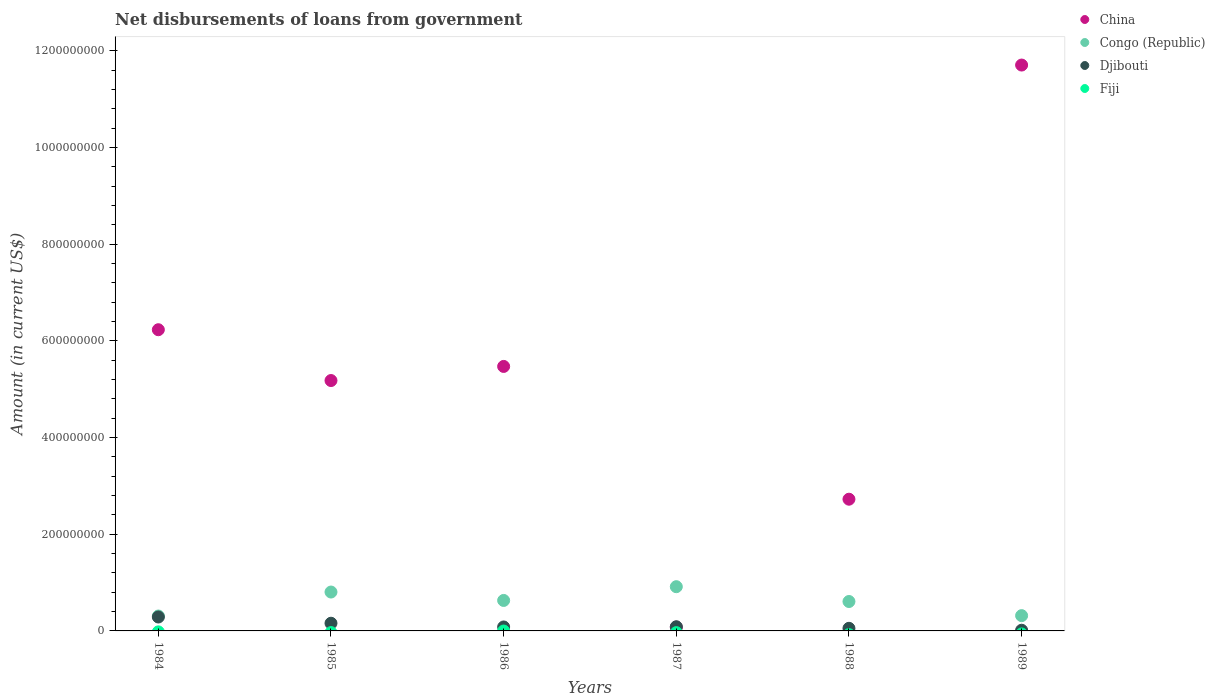How many different coloured dotlines are there?
Ensure brevity in your answer.  3. What is the amount of loan disbursed from government in Congo (Republic) in 1988?
Offer a terse response. 6.09e+07. Across all years, what is the maximum amount of loan disbursed from government in Congo (Republic)?
Provide a short and direct response. 9.15e+07. Across all years, what is the minimum amount of loan disbursed from government in Congo (Republic)?
Keep it short and to the point. 3.08e+07. What is the total amount of loan disbursed from government in China in the graph?
Your answer should be compact. 3.14e+09. What is the difference between the amount of loan disbursed from government in China in 1984 and that in 1989?
Ensure brevity in your answer.  -5.48e+08. What is the difference between the amount of loan disbursed from government in Congo (Republic) in 1985 and the amount of loan disbursed from government in Djibouti in 1986?
Ensure brevity in your answer.  7.22e+07. What is the average amount of loan disbursed from government in Djibouti per year?
Give a very brief answer. 1.14e+07. In the year 1989, what is the difference between the amount of loan disbursed from government in Djibouti and amount of loan disbursed from government in China?
Give a very brief answer. -1.17e+09. In how many years, is the amount of loan disbursed from government in Djibouti greater than 800000000 US$?
Give a very brief answer. 0. What is the ratio of the amount of loan disbursed from government in Congo (Republic) in 1986 to that in 1988?
Offer a very short reply. 1.04. What is the difference between the highest and the second highest amount of loan disbursed from government in Congo (Republic)?
Provide a succinct answer. 1.11e+07. What is the difference between the highest and the lowest amount of loan disbursed from government in Djibouti?
Your response must be concise. 2.74e+07. Is it the case that in every year, the sum of the amount of loan disbursed from government in Congo (Republic) and amount of loan disbursed from government in Djibouti  is greater than the sum of amount of loan disbursed from government in Fiji and amount of loan disbursed from government in China?
Offer a very short reply. No. Does the amount of loan disbursed from government in China monotonically increase over the years?
Provide a succinct answer. No. Is the amount of loan disbursed from government in Fiji strictly less than the amount of loan disbursed from government in Congo (Republic) over the years?
Your answer should be compact. Yes. How many dotlines are there?
Offer a very short reply. 3. Are the values on the major ticks of Y-axis written in scientific E-notation?
Provide a short and direct response. No. Does the graph contain any zero values?
Your answer should be compact. Yes. Where does the legend appear in the graph?
Your response must be concise. Top right. How many legend labels are there?
Keep it short and to the point. 4. What is the title of the graph?
Provide a succinct answer. Net disbursements of loans from government. Does "East Asia (developing only)" appear as one of the legend labels in the graph?
Offer a very short reply. No. What is the label or title of the X-axis?
Your answer should be very brief. Years. What is the Amount (in current US$) of China in 1984?
Your response must be concise. 6.23e+08. What is the Amount (in current US$) of Congo (Republic) in 1984?
Provide a short and direct response. 3.08e+07. What is the Amount (in current US$) in Djibouti in 1984?
Offer a very short reply. 2.88e+07. What is the Amount (in current US$) of China in 1985?
Your response must be concise. 5.18e+08. What is the Amount (in current US$) of Congo (Republic) in 1985?
Keep it short and to the point. 8.04e+07. What is the Amount (in current US$) of Djibouti in 1985?
Provide a short and direct response. 1.59e+07. What is the Amount (in current US$) of Fiji in 1985?
Provide a succinct answer. 0. What is the Amount (in current US$) of China in 1986?
Provide a short and direct response. 5.47e+08. What is the Amount (in current US$) in Congo (Republic) in 1986?
Keep it short and to the point. 6.30e+07. What is the Amount (in current US$) of Djibouti in 1986?
Your response must be concise. 8.19e+06. What is the Amount (in current US$) in Fiji in 1986?
Keep it short and to the point. 0. What is the Amount (in current US$) in China in 1987?
Your answer should be compact. 7.75e+06. What is the Amount (in current US$) of Congo (Republic) in 1987?
Your answer should be compact. 9.15e+07. What is the Amount (in current US$) of Djibouti in 1987?
Ensure brevity in your answer.  8.63e+06. What is the Amount (in current US$) of China in 1988?
Your answer should be compact. 2.72e+08. What is the Amount (in current US$) in Congo (Republic) in 1988?
Your answer should be very brief. 6.09e+07. What is the Amount (in current US$) in Djibouti in 1988?
Your answer should be compact. 5.40e+06. What is the Amount (in current US$) of China in 1989?
Provide a succinct answer. 1.17e+09. What is the Amount (in current US$) in Congo (Republic) in 1989?
Provide a short and direct response. 3.16e+07. What is the Amount (in current US$) of Djibouti in 1989?
Your answer should be very brief. 1.43e+06. What is the Amount (in current US$) of Fiji in 1989?
Provide a short and direct response. 0. Across all years, what is the maximum Amount (in current US$) of China?
Keep it short and to the point. 1.17e+09. Across all years, what is the maximum Amount (in current US$) in Congo (Republic)?
Offer a terse response. 9.15e+07. Across all years, what is the maximum Amount (in current US$) of Djibouti?
Make the answer very short. 2.88e+07. Across all years, what is the minimum Amount (in current US$) in China?
Offer a very short reply. 7.75e+06. Across all years, what is the minimum Amount (in current US$) of Congo (Republic)?
Ensure brevity in your answer.  3.08e+07. Across all years, what is the minimum Amount (in current US$) of Djibouti?
Your answer should be compact. 1.43e+06. What is the total Amount (in current US$) in China in the graph?
Keep it short and to the point. 3.14e+09. What is the total Amount (in current US$) in Congo (Republic) in the graph?
Your answer should be compact. 3.58e+08. What is the total Amount (in current US$) in Djibouti in the graph?
Keep it short and to the point. 6.83e+07. What is the difference between the Amount (in current US$) of China in 1984 and that in 1985?
Provide a succinct answer. 1.05e+08. What is the difference between the Amount (in current US$) of Congo (Republic) in 1984 and that in 1985?
Provide a succinct answer. -4.96e+07. What is the difference between the Amount (in current US$) in Djibouti in 1984 and that in 1985?
Provide a succinct answer. 1.29e+07. What is the difference between the Amount (in current US$) in China in 1984 and that in 1986?
Ensure brevity in your answer.  7.59e+07. What is the difference between the Amount (in current US$) of Congo (Republic) in 1984 and that in 1986?
Provide a short and direct response. -3.22e+07. What is the difference between the Amount (in current US$) in Djibouti in 1984 and that in 1986?
Your answer should be compact. 2.06e+07. What is the difference between the Amount (in current US$) in China in 1984 and that in 1987?
Your answer should be compact. 6.15e+08. What is the difference between the Amount (in current US$) of Congo (Republic) in 1984 and that in 1987?
Ensure brevity in your answer.  -6.07e+07. What is the difference between the Amount (in current US$) of Djibouti in 1984 and that in 1987?
Make the answer very short. 2.02e+07. What is the difference between the Amount (in current US$) in China in 1984 and that in 1988?
Your response must be concise. 3.51e+08. What is the difference between the Amount (in current US$) in Congo (Republic) in 1984 and that in 1988?
Your response must be concise. -3.00e+07. What is the difference between the Amount (in current US$) in Djibouti in 1984 and that in 1988?
Give a very brief answer. 2.34e+07. What is the difference between the Amount (in current US$) of China in 1984 and that in 1989?
Offer a very short reply. -5.48e+08. What is the difference between the Amount (in current US$) in Congo (Republic) in 1984 and that in 1989?
Your answer should be compact. -7.80e+05. What is the difference between the Amount (in current US$) in Djibouti in 1984 and that in 1989?
Your answer should be very brief. 2.74e+07. What is the difference between the Amount (in current US$) of China in 1985 and that in 1986?
Keep it short and to the point. -2.92e+07. What is the difference between the Amount (in current US$) in Congo (Republic) in 1985 and that in 1986?
Give a very brief answer. 1.74e+07. What is the difference between the Amount (in current US$) of Djibouti in 1985 and that in 1986?
Offer a very short reply. 7.72e+06. What is the difference between the Amount (in current US$) of China in 1985 and that in 1987?
Ensure brevity in your answer.  5.10e+08. What is the difference between the Amount (in current US$) of Congo (Republic) in 1985 and that in 1987?
Your answer should be very brief. -1.11e+07. What is the difference between the Amount (in current US$) in Djibouti in 1985 and that in 1987?
Ensure brevity in your answer.  7.28e+06. What is the difference between the Amount (in current US$) of China in 1985 and that in 1988?
Your response must be concise. 2.45e+08. What is the difference between the Amount (in current US$) of Congo (Republic) in 1985 and that in 1988?
Provide a succinct answer. 1.96e+07. What is the difference between the Amount (in current US$) of Djibouti in 1985 and that in 1988?
Offer a terse response. 1.05e+07. What is the difference between the Amount (in current US$) of China in 1985 and that in 1989?
Offer a very short reply. -6.53e+08. What is the difference between the Amount (in current US$) of Congo (Republic) in 1985 and that in 1989?
Ensure brevity in your answer.  4.88e+07. What is the difference between the Amount (in current US$) in Djibouti in 1985 and that in 1989?
Provide a succinct answer. 1.45e+07. What is the difference between the Amount (in current US$) in China in 1986 and that in 1987?
Your answer should be compact. 5.39e+08. What is the difference between the Amount (in current US$) of Congo (Republic) in 1986 and that in 1987?
Ensure brevity in your answer.  -2.85e+07. What is the difference between the Amount (in current US$) in Djibouti in 1986 and that in 1987?
Give a very brief answer. -4.40e+05. What is the difference between the Amount (in current US$) of China in 1986 and that in 1988?
Make the answer very short. 2.75e+08. What is the difference between the Amount (in current US$) in Congo (Republic) in 1986 and that in 1988?
Provide a succinct answer. 2.18e+06. What is the difference between the Amount (in current US$) in Djibouti in 1986 and that in 1988?
Give a very brief answer. 2.79e+06. What is the difference between the Amount (in current US$) of China in 1986 and that in 1989?
Provide a short and direct response. -6.23e+08. What is the difference between the Amount (in current US$) in Congo (Republic) in 1986 and that in 1989?
Provide a succinct answer. 3.14e+07. What is the difference between the Amount (in current US$) in Djibouti in 1986 and that in 1989?
Make the answer very short. 6.76e+06. What is the difference between the Amount (in current US$) of China in 1987 and that in 1988?
Give a very brief answer. -2.65e+08. What is the difference between the Amount (in current US$) in Congo (Republic) in 1987 and that in 1988?
Ensure brevity in your answer.  3.06e+07. What is the difference between the Amount (in current US$) in Djibouti in 1987 and that in 1988?
Ensure brevity in your answer.  3.23e+06. What is the difference between the Amount (in current US$) in China in 1987 and that in 1989?
Give a very brief answer. -1.16e+09. What is the difference between the Amount (in current US$) in Congo (Republic) in 1987 and that in 1989?
Provide a short and direct response. 5.99e+07. What is the difference between the Amount (in current US$) of Djibouti in 1987 and that in 1989?
Give a very brief answer. 7.20e+06. What is the difference between the Amount (in current US$) of China in 1988 and that in 1989?
Offer a terse response. -8.98e+08. What is the difference between the Amount (in current US$) in Congo (Republic) in 1988 and that in 1989?
Give a very brief answer. 2.92e+07. What is the difference between the Amount (in current US$) in Djibouti in 1988 and that in 1989?
Provide a succinct answer. 3.97e+06. What is the difference between the Amount (in current US$) in China in 1984 and the Amount (in current US$) in Congo (Republic) in 1985?
Your answer should be compact. 5.43e+08. What is the difference between the Amount (in current US$) of China in 1984 and the Amount (in current US$) of Djibouti in 1985?
Make the answer very short. 6.07e+08. What is the difference between the Amount (in current US$) of Congo (Republic) in 1984 and the Amount (in current US$) of Djibouti in 1985?
Keep it short and to the point. 1.49e+07. What is the difference between the Amount (in current US$) in China in 1984 and the Amount (in current US$) in Congo (Republic) in 1986?
Your answer should be very brief. 5.60e+08. What is the difference between the Amount (in current US$) of China in 1984 and the Amount (in current US$) of Djibouti in 1986?
Provide a short and direct response. 6.15e+08. What is the difference between the Amount (in current US$) in Congo (Republic) in 1984 and the Amount (in current US$) in Djibouti in 1986?
Offer a terse response. 2.26e+07. What is the difference between the Amount (in current US$) in China in 1984 and the Amount (in current US$) in Congo (Republic) in 1987?
Your answer should be compact. 5.32e+08. What is the difference between the Amount (in current US$) in China in 1984 and the Amount (in current US$) in Djibouti in 1987?
Provide a succinct answer. 6.14e+08. What is the difference between the Amount (in current US$) of Congo (Republic) in 1984 and the Amount (in current US$) of Djibouti in 1987?
Give a very brief answer. 2.22e+07. What is the difference between the Amount (in current US$) in China in 1984 and the Amount (in current US$) in Congo (Republic) in 1988?
Provide a succinct answer. 5.62e+08. What is the difference between the Amount (in current US$) of China in 1984 and the Amount (in current US$) of Djibouti in 1988?
Ensure brevity in your answer.  6.18e+08. What is the difference between the Amount (in current US$) in Congo (Republic) in 1984 and the Amount (in current US$) in Djibouti in 1988?
Your answer should be very brief. 2.54e+07. What is the difference between the Amount (in current US$) of China in 1984 and the Amount (in current US$) of Congo (Republic) in 1989?
Your response must be concise. 5.91e+08. What is the difference between the Amount (in current US$) in China in 1984 and the Amount (in current US$) in Djibouti in 1989?
Ensure brevity in your answer.  6.22e+08. What is the difference between the Amount (in current US$) in Congo (Republic) in 1984 and the Amount (in current US$) in Djibouti in 1989?
Ensure brevity in your answer.  2.94e+07. What is the difference between the Amount (in current US$) of China in 1985 and the Amount (in current US$) of Congo (Republic) in 1986?
Keep it short and to the point. 4.55e+08. What is the difference between the Amount (in current US$) in China in 1985 and the Amount (in current US$) in Djibouti in 1986?
Offer a very short reply. 5.10e+08. What is the difference between the Amount (in current US$) in Congo (Republic) in 1985 and the Amount (in current US$) in Djibouti in 1986?
Your response must be concise. 7.22e+07. What is the difference between the Amount (in current US$) in China in 1985 and the Amount (in current US$) in Congo (Republic) in 1987?
Ensure brevity in your answer.  4.26e+08. What is the difference between the Amount (in current US$) in China in 1985 and the Amount (in current US$) in Djibouti in 1987?
Provide a succinct answer. 5.09e+08. What is the difference between the Amount (in current US$) of Congo (Republic) in 1985 and the Amount (in current US$) of Djibouti in 1987?
Your answer should be very brief. 7.18e+07. What is the difference between the Amount (in current US$) in China in 1985 and the Amount (in current US$) in Congo (Republic) in 1988?
Ensure brevity in your answer.  4.57e+08. What is the difference between the Amount (in current US$) of China in 1985 and the Amount (in current US$) of Djibouti in 1988?
Offer a terse response. 5.13e+08. What is the difference between the Amount (in current US$) in Congo (Republic) in 1985 and the Amount (in current US$) in Djibouti in 1988?
Your answer should be very brief. 7.50e+07. What is the difference between the Amount (in current US$) of China in 1985 and the Amount (in current US$) of Congo (Republic) in 1989?
Offer a very short reply. 4.86e+08. What is the difference between the Amount (in current US$) in China in 1985 and the Amount (in current US$) in Djibouti in 1989?
Keep it short and to the point. 5.17e+08. What is the difference between the Amount (in current US$) of Congo (Republic) in 1985 and the Amount (in current US$) of Djibouti in 1989?
Offer a terse response. 7.90e+07. What is the difference between the Amount (in current US$) in China in 1986 and the Amount (in current US$) in Congo (Republic) in 1987?
Provide a succinct answer. 4.56e+08. What is the difference between the Amount (in current US$) of China in 1986 and the Amount (in current US$) of Djibouti in 1987?
Give a very brief answer. 5.39e+08. What is the difference between the Amount (in current US$) in Congo (Republic) in 1986 and the Amount (in current US$) in Djibouti in 1987?
Your answer should be very brief. 5.44e+07. What is the difference between the Amount (in current US$) of China in 1986 and the Amount (in current US$) of Congo (Republic) in 1988?
Offer a terse response. 4.86e+08. What is the difference between the Amount (in current US$) of China in 1986 and the Amount (in current US$) of Djibouti in 1988?
Provide a succinct answer. 5.42e+08. What is the difference between the Amount (in current US$) of Congo (Republic) in 1986 and the Amount (in current US$) of Djibouti in 1988?
Ensure brevity in your answer.  5.76e+07. What is the difference between the Amount (in current US$) in China in 1986 and the Amount (in current US$) in Congo (Republic) in 1989?
Your answer should be very brief. 5.16e+08. What is the difference between the Amount (in current US$) in China in 1986 and the Amount (in current US$) in Djibouti in 1989?
Your answer should be very brief. 5.46e+08. What is the difference between the Amount (in current US$) in Congo (Republic) in 1986 and the Amount (in current US$) in Djibouti in 1989?
Your answer should be compact. 6.16e+07. What is the difference between the Amount (in current US$) of China in 1987 and the Amount (in current US$) of Congo (Republic) in 1988?
Provide a short and direct response. -5.31e+07. What is the difference between the Amount (in current US$) in China in 1987 and the Amount (in current US$) in Djibouti in 1988?
Ensure brevity in your answer.  2.35e+06. What is the difference between the Amount (in current US$) of Congo (Republic) in 1987 and the Amount (in current US$) of Djibouti in 1988?
Your response must be concise. 8.61e+07. What is the difference between the Amount (in current US$) of China in 1987 and the Amount (in current US$) of Congo (Republic) in 1989?
Your answer should be very brief. -2.39e+07. What is the difference between the Amount (in current US$) of China in 1987 and the Amount (in current US$) of Djibouti in 1989?
Your answer should be very brief. 6.32e+06. What is the difference between the Amount (in current US$) in Congo (Republic) in 1987 and the Amount (in current US$) in Djibouti in 1989?
Your answer should be very brief. 9.01e+07. What is the difference between the Amount (in current US$) in China in 1988 and the Amount (in current US$) in Congo (Republic) in 1989?
Your answer should be compact. 2.41e+08. What is the difference between the Amount (in current US$) in China in 1988 and the Amount (in current US$) in Djibouti in 1989?
Offer a terse response. 2.71e+08. What is the difference between the Amount (in current US$) of Congo (Republic) in 1988 and the Amount (in current US$) of Djibouti in 1989?
Provide a short and direct response. 5.94e+07. What is the average Amount (in current US$) of China per year?
Your response must be concise. 5.23e+08. What is the average Amount (in current US$) in Congo (Republic) per year?
Your answer should be compact. 5.97e+07. What is the average Amount (in current US$) of Djibouti per year?
Provide a succinct answer. 1.14e+07. In the year 1984, what is the difference between the Amount (in current US$) in China and Amount (in current US$) in Congo (Republic)?
Provide a succinct answer. 5.92e+08. In the year 1984, what is the difference between the Amount (in current US$) in China and Amount (in current US$) in Djibouti?
Give a very brief answer. 5.94e+08. In the year 1984, what is the difference between the Amount (in current US$) in Congo (Republic) and Amount (in current US$) in Djibouti?
Provide a short and direct response. 2.04e+06. In the year 1985, what is the difference between the Amount (in current US$) of China and Amount (in current US$) of Congo (Republic)?
Your response must be concise. 4.38e+08. In the year 1985, what is the difference between the Amount (in current US$) in China and Amount (in current US$) in Djibouti?
Offer a terse response. 5.02e+08. In the year 1985, what is the difference between the Amount (in current US$) in Congo (Republic) and Amount (in current US$) in Djibouti?
Keep it short and to the point. 6.45e+07. In the year 1986, what is the difference between the Amount (in current US$) in China and Amount (in current US$) in Congo (Republic)?
Make the answer very short. 4.84e+08. In the year 1986, what is the difference between the Amount (in current US$) of China and Amount (in current US$) of Djibouti?
Your answer should be compact. 5.39e+08. In the year 1986, what is the difference between the Amount (in current US$) of Congo (Republic) and Amount (in current US$) of Djibouti?
Your response must be concise. 5.48e+07. In the year 1987, what is the difference between the Amount (in current US$) in China and Amount (in current US$) in Congo (Republic)?
Keep it short and to the point. -8.37e+07. In the year 1987, what is the difference between the Amount (in current US$) of China and Amount (in current US$) of Djibouti?
Your answer should be compact. -8.79e+05. In the year 1987, what is the difference between the Amount (in current US$) of Congo (Republic) and Amount (in current US$) of Djibouti?
Offer a very short reply. 8.29e+07. In the year 1988, what is the difference between the Amount (in current US$) of China and Amount (in current US$) of Congo (Republic)?
Ensure brevity in your answer.  2.12e+08. In the year 1988, what is the difference between the Amount (in current US$) of China and Amount (in current US$) of Djibouti?
Keep it short and to the point. 2.67e+08. In the year 1988, what is the difference between the Amount (in current US$) in Congo (Republic) and Amount (in current US$) in Djibouti?
Your answer should be compact. 5.55e+07. In the year 1989, what is the difference between the Amount (in current US$) in China and Amount (in current US$) in Congo (Republic)?
Your answer should be very brief. 1.14e+09. In the year 1989, what is the difference between the Amount (in current US$) of China and Amount (in current US$) of Djibouti?
Your answer should be compact. 1.17e+09. In the year 1989, what is the difference between the Amount (in current US$) of Congo (Republic) and Amount (in current US$) of Djibouti?
Provide a succinct answer. 3.02e+07. What is the ratio of the Amount (in current US$) in China in 1984 to that in 1985?
Offer a very short reply. 1.2. What is the ratio of the Amount (in current US$) of Congo (Republic) in 1984 to that in 1985?
Ensure brevity in your answer.  0.38. What is the ratio of the Amount (in current US$) of Djibouti in 1984 to that in 1985?
Make the answer very short. 1.81. What is the ratio of the Amount (in current US$) of China in 1984 to that in 1986?
Provide a short and direct response. 1.14. What is the ratio of the Amount (in current US$) of Congo (Republic) in 1984 to that in 1986?
Offer a terse response. 0.49. What is the ratio of the Amount (in current US$) of Djibouti in 1984 to that in 1986?
Your response must be concise. 3.52. What is the ratio of the Amount (in current US$) in China in 1984 to that in 1987?
Give a very brief answer. 80.4. What is the ratio of the Amount (in current US$) in Congo (Republic) in 1984 to that in 1987?
Your response must be concise. 0.34. What is the ratio of the Amount (in current US$) of Djibouti in 1984 to that in 1987?
Provide a short and direct response. 3.34. What is the ratio of the Amount (in current US$) of China in 1984 to that in 1988?
Offer a very short reply. 2.29. What is the ratio of the Amount (in current US$) in Congo (Republic) in 1984 to that in 1988?
Provide a short and direct response. 0.51. What is the ratio of the Amount (in current US$) in Djibouti in 1984 to that in 1988?
Provide a succinct answer. 5.33. What is the ratio of the Amount (in current US$) in China in 1984 to that in 1989?
Make the answer very short. 0.53. What is the ratio of the Amount (in current US$) of Congo (Republic) in 1984 to that in 1989?
Your response must be concise. 0.98. What is the ratio of the Amount (in current US$) in Djibouti in 1984 to that in 1989?
Give a very brief answer. 20.16. What is the ratio of the Amount (in current US$) in China in 1985 to that in 1986?
Your response must be concise. 0.95. What is the ratio of the Amount (in current US$) in Congo (Republic) in 1985 to that in 1986?
Your answer should be compact. 1.28. What is the ratio of the Amount (in current US$) in Djibouti in 1985 to that in 1986?
Offer a terse response. 1.94. What is the ratio of the Amount (in current US$) of China in 1985 to that in 1987?
Provide a short and direct response. 66.83. What is the ratio of the Amount (in current US$) in Congo (Republic) in 1985 to that in 1987?
Offer a very short reply. 0.88. What is the ratio of the Amount (in current US$) in Djibouti in 1985 to that in 1987?
Your response must be concise. 1.84. What is the ratio of the Amount (in current US$) of China in 1985 to that in 1988?
Give a very brief answer. 1.9. What is the ratio of the Amount (in current US$) of Congo (Republic) in 1985 to that in 1988?
Give a very brief answer. 1.32. What is the ratio of the Amount (in current US$) in Djibouti in 1985 to that in 1988?
Your response must be concise. 2.95. What is the ratio of the Amount (in current US$) in China in 1985 to that in 1989?
Keep it short and to the point. 0.44. What is the ratio of the Amount (in current US$) of Congo (Republic) in 1985 to that in 1989?
Provide a succinct answer. 2.54. What is the ratio of the Amount (in current US$) in Djibouti in 1985 to that in 1989?
Your answer should be very brief. 11.14. What is the ratio of the Amount (in current US$) of China in 1986 to that in 1987?
Provide a succinct answer. 70.6. What is the ratio of the Amount (in current US$) in Congo (Republic) in 1986 to that in 1987?
Offer a very short reply. 0.69. What is the ratio of the Amount (in current US$) in Djibouti in 1986 to that in 1987?
Provide a succinct answer. 0.95. What is the ratio of the Amount (in current US$) in China in 1986 to that in 1988?
Your answer should be compact. 2.01. What is the ratio of the Amount (in current US$) of Congo (Republic) in 1986 to that in 1988?
Your response must be concise. 1.04. What is the ratio of the Amount (in current US$) in Djibouti in 1986 to that in 1988?
Offer a very short reply. 1.52. What is the ratio of the Amount (in current US$) in China in 1986 to that in 1989?
Make the answer very short. 0.47. What is the ratio of the Amount (in current US$) of Congo (Republic) in 1986 to that in 1989?
Keep it short and to the point. 1.99. What is the ratio of the Amount (in current US$) of Djibouti in 1986 to that in 1989?
Your answer should be very brief. 5.73. What is the ratio of the Amount (in current US$) of China in 1987 to that in 1988?
Keep it short and to the point. 0.03. What is the ratio of the Amount (in current US$) in Congo (Republic) in 1987 to that in 1988?
Offer a terse response. 1.5. What is the ratio of the Amount (in current US$) in Djibouti in 1987 to that in 1988?
Your response must be concise. 1.6. What is the ratio of the Amount (in current US$) of China in 1987 to that in 1989?
Make the answer very short. 0.01. What is the ratio of the Amount (in current US$) of Congo (Republic) in 1987 to that in 1989?
Give a very brief answer. 2.89. What is the ratio of the Amount (in current US$) in Djibouti in 1987 to that in 1989?
Your response must be concise. 6.04. What is the ratio of the Amount (in current US$) in China in 1988 to that in 1989?
Your answer should be very brief. 0.23. What is the ratio of the Amount (in current US$) in Congo (Republic) in 1988 to that in 1989?
Your response must be concise. 1.93. What is the ratio of the Amount (in current US$) in Djibouti in 1988 to that in 1989?
Ensure brevity in your answer.  3.78. What is the difference between the highest and the second highest Amount (in current US$) of China?
Offer a terse response. 5.48e+08. What is the difference between the highest and the second highest Amount (in current US$) in Congo (Republic)?
Keep it short and to the point. 1.11e+07. What is the difference between the highest and the second highest Amount (in current US$) of Djibouti?
Your answer should be compact. 1.29e+07. What is the difference between the highest and the lowest Amount (in current US$) of China?
Your answer should be compact. 1.16e+09. What is the difference between the highest and the lowest Amount (in current US$) in Congo (Republic)?
Keep it short and to the point. 6.07e+07. What is the difference between the highest and the lowest Amount (in current US$) in Djibouti?
Your answer should be very brief. 2.74e+07. 